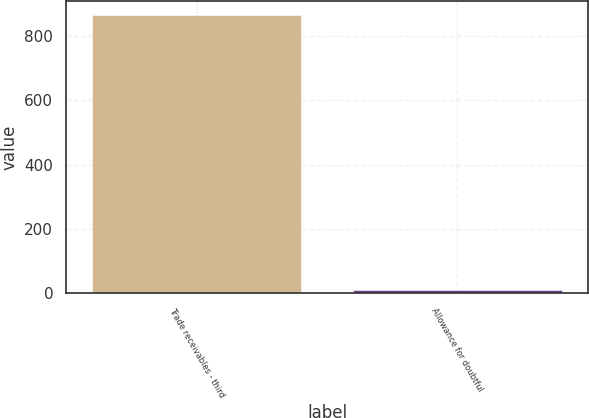Convert chart. <chart><loc_0><loc_0><loc_500><loc_500><bar_chart><fcel>Trade receivables - third<fcel>Allowance for doubtful<nl><fcel>867<fcel>9<nl></chart> 